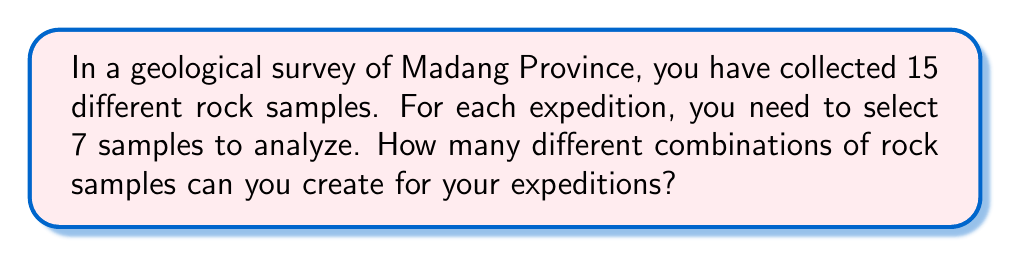Give your solution to this math problem. Let's approach this step-by-step:

1) This is a combination problem. We are selecting 7 samples out of 15, where the order doesn't matter (it's not important which sample we pick first, second, etc.).

2) The formula for combinations is:

   $$C(n,r) = \frac{n!}{r!(n-r)!}$$

   Where $n$ is the total number of items to choose from, and $r$ is the number of items being chosen.

3) In this case, $n = 15$ (total rock samples) and $r = 7$ (samples selected for each expedition).

4) Let's substitute these values into our formula:

   $$C(15,7) = \frac{15!}{7!(15-7)!} = \frac{15!}{7!8!}$$

5) Expand this:
   $$\frac{15 \times 14 \times 13 \times 12 \times 11 \times 10 \times 9 \times 8!}{(7 \times 6 \times 5 \times 4 \times 3 \times 2 \times 1) \times 8!}$$

6) The $8!$ cancels out in the numerator and denominator:

   $$\frac{15 \times 14 \times 13 \times 12 \times 11 \times 10 \times 9}{7 \times 6 \times 5 \times 4 \times 3 \times 2 \times 1}$$

7) Multiply the numerator and denominator:
   $$\frac{360,360}{5,040} = 6,435$$

Therefore, there are 6,435 different possible combinations of rock samples for your expeditions.
Answer: 6,435 